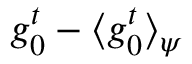<formula> <loc_0><loc_0><loc_500><loc_500>g _ { 0 } ^ { t } - \langle g _ { 0 } ^ { t } \rangle _ { \psi }</formula> 